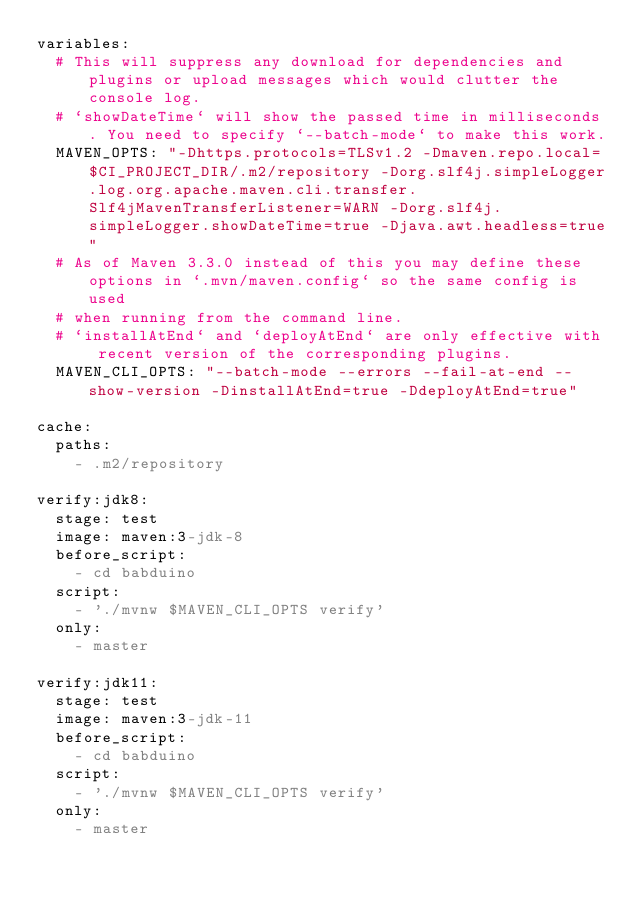<code> <loc_0><loc_0><loc_500><loc_500><_YAML_>variables:
  # This will suppress any download for dependencies and plugins or upload messages which would clutter the console log.
  # `showDateTime` will show the passed time in milliseconds. You need to specify `--batch-mode` to make this work.
  MAVEN_OPTS: "-Dhttps.protocols=TLSv1.2 -Dmaven.repo.local=$CI_PROJECT_DIR/.m2/repository -Dorg.slf4j.simpleLogger.log.org.apache.maven.cli.transfer.Slf4jMavenTransferListener=WARN -Dorg.slf4j.simpleLogger.showDateTime=true -Djava.awt.headless=true"
  # As of Maven 3.3.0 instead of this you may define these options in `.mvn/maven.config` so the same config is used
  # when running from the command line.
  # `installAtEnd` and `deployAtEnd` are only effective with recent version of the corresponding plugins.
  MAVEN_CLI_OPTS: "--batch-mode --errors --fail-at-end --show-version -DinstallAtEnd=true -DdeployAtEnd=true"

cache:
  paths:
    - .m2/repository

verify:jdk8:
  stage: test
  image: maven:3-jdk-8
  before_script:
    - cd babduino
  script:
    - './mvnw $MAVEN_CLI_OPTS verify'
  only:
    - master

verify:jdk11:
  stage: test
  image: maven:3-jdk-11
  before_script:
    - cd babduino
  script:
    - './mvnw $MAVEN_CLI_OPTS verify'
  only:
    - master
</code> 